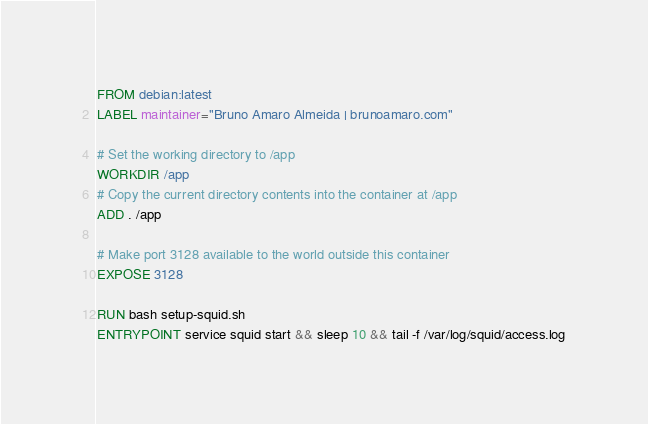<code> <loc_0><loc_0><loc_500><loc_500><_Dockerfile_>FROM debian:latest
LABEL maintainer="Bruno Amaro Almeida | brunoamaro.com"

# Set the working directory to /app
WORKDIR /app
# Copy the current directory contents into the container at /app
ADD . /app

# Make port 3128 available to the world outside this container
EXPOSE 3128

RUN bash setup-squid.sh
ENTRYPOINT service squid start && sleep 10 && tail -f /var/log/squid/access.log
</code> 